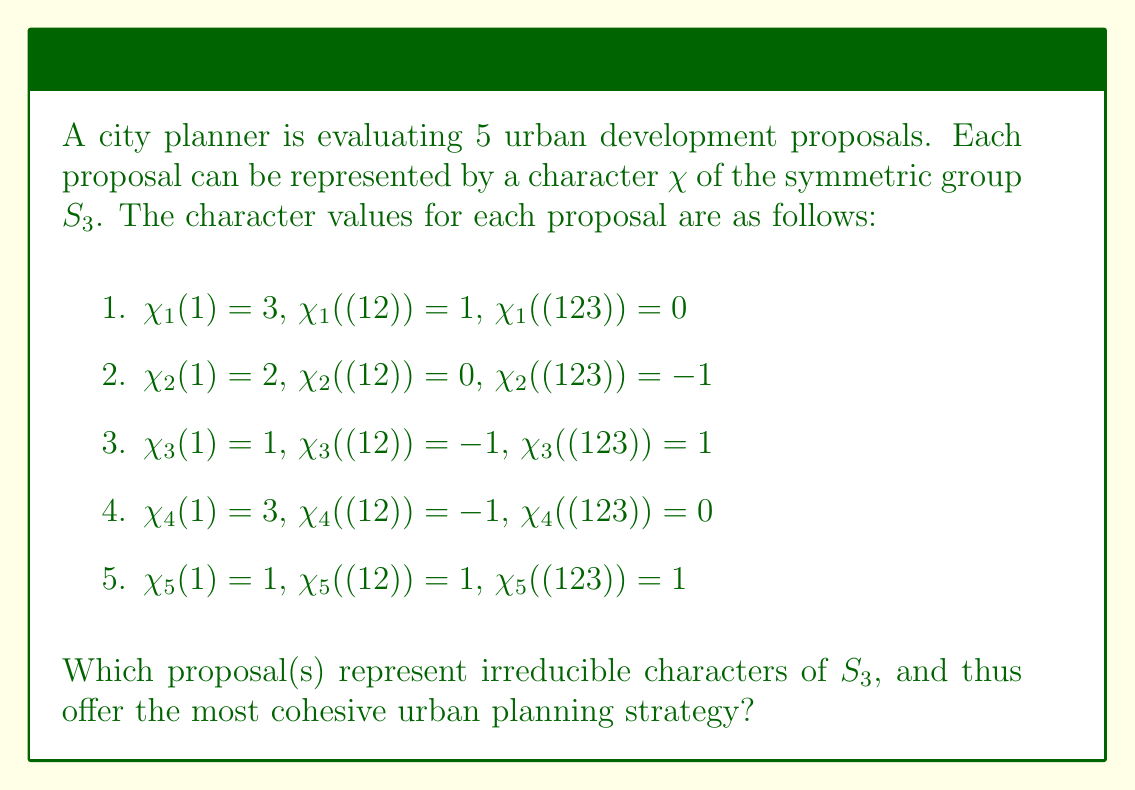Solve this math problem. To determine which characters are irreducible, we'll use the following steps:

1. Recall that $S_3$ has 3 conjugacy classes: $\{1\}$, $\{(12), (13), (23)\}$, and $\{(123), (132)\}$.

2. The sum of squares of dimensions of irreducible characters equals the order of the group. For $S_3$, we have $|S_3| = 6$.

3. We'll use the orthogonality relation for irreducible characters:

   $$\frac{1}{|G|} \sum_{g \in G} |\chi(g)|^2 = 1$$

4. For each character, calculate:

   $$\frac{1}{6}(|\chi(1)|^2 + 3|\chi((12))|^2 + 2|\chi((123))|^2) = 1$$

5. Evaluating for each character:

   $\chi_1$: $\frac{1}{6}(3^2 + 3(1^2) + 2(0^2)) = \frac{12}{6} = 2 \neq 1$
   $\chi_2$: $\frac{1}{6}(2^2 + 3(0^2) + 2(-1^2)) = \frac{6}{6} = 1$
   $\chi_3$: $\frac{1}{6}(1^2 + 3(-1^2) + 2(1^2)) = \frac{6}{6} = 1$
   $\chi_4$: $\frac{1}{6}(3^2 + 3(-1^2) + 2(0^2)) = \frac{12}{6} = 2 \neq 1$
   $\chi_5$: $\frac{1}{6}(1^2 + 3(1^2) + 2(1^2)) = 1$

6. Characters $\chi_2$, $\chi_3$, and $\chi_5$ satisfy the orthogonality relation and are thus irreducible.

7. We can verify that these are indeed the irreducible characters of $S_3$:
   - $\chi_2$ is the standard representation
   - $\chi_3$ is the sign representation
   - $\chi_5$ is the trivial representation
Answer: Proposals 2, 3, and 5 